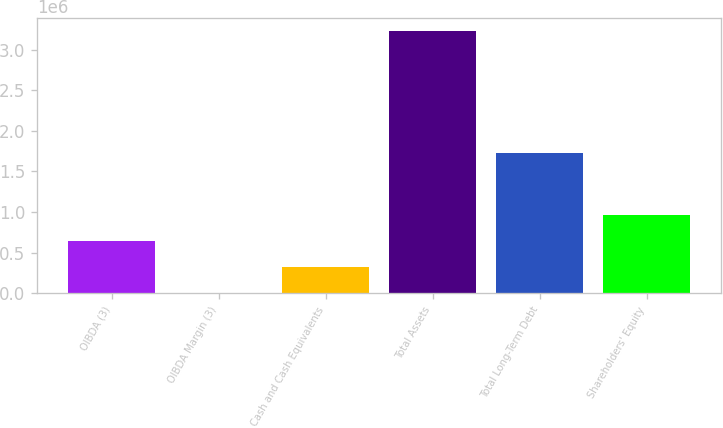Convert chart to OTSL. <chart><loc_0><loc_0><loc_500><loc_500><bar_chart><fcel>OIBDA (3)<fcel>OIBDA Margin (3)<fcel>Cash and Cash Equivalents<fcel>Total Assets<fcel>Total Long-Term Debt<fcel>Shareholders' Equity<nl><fcel>646153<fcel>27.4<fcel>323090<fcel>3.23066e+06<fcel>1.7321e+06<fcel>969216<nl></chart> 